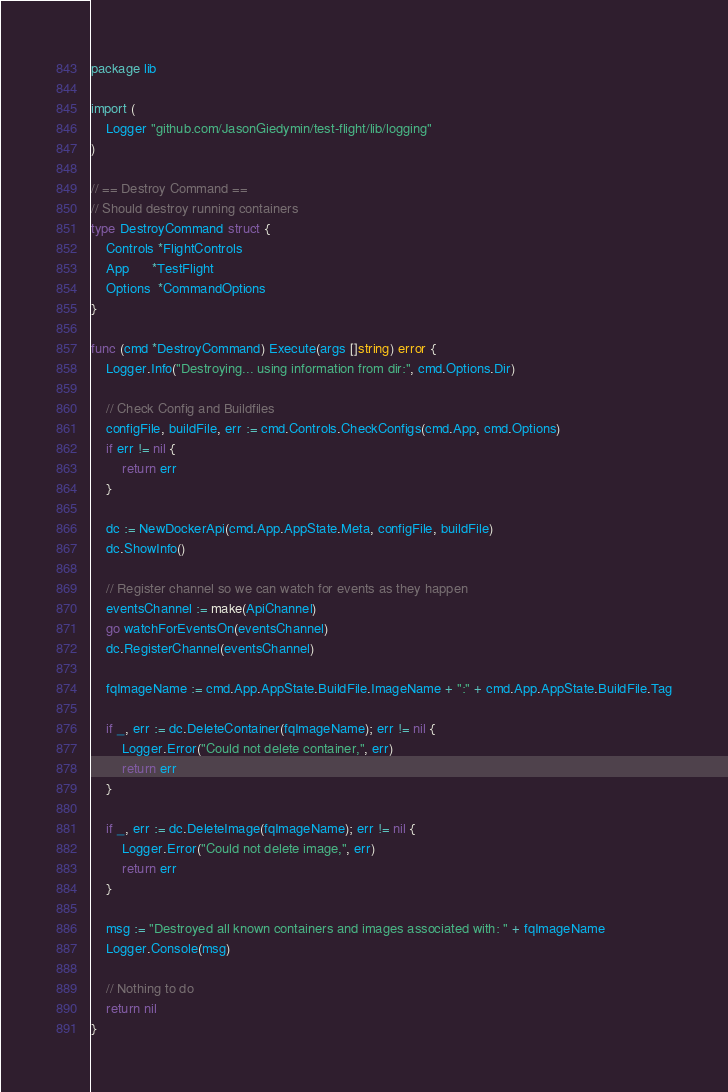<code> <loc_0><loc_0><loc_500><loc_500><_Go_>package lib

import (
    Logger "github.com/JasonGiedymin/test-flight/lib/logging"
)

// == Destroy Command ==
// Should destroy running containers
type DestroyCommand struct {
    Controls *FlightControls
    App      *TestFlight
    Options  *CommandOptions
}

func (cmd *DestroyCommand) Execute(args []string) error {
    Logger.Info("Destroying... using information from dir:", cmd.Options.Dir)

    // Check Config and Buildfiles
    configFile, buildFile, err := cmd.Controls.CheckConfigs(cmd.App, cmd.Options)
    if err != nil {
        return err
    }

    dc := NewDockerApi(cmd.App.AppState.Meta, configFile, buildFile)
    dc.ShowInfo()

    // Register channel so we can watch for events as they happen
    eventsChannel := make(ApiChannel)
    go watchForEventsOn(eventsChannel)
    dc.RegisterChannel(eventsChannel)

    fqImageName := cmd.App.AppState.BuildFile.ImageName + ":" + cmd.App.AppState.BuildFile.Tag

    if _, err := dc.DeleteContainer(fqImageName); err != nil {
        Logger.Error("Could not delete container,", err)
        return err
    }

    if _, err := dc.DeleteImage(fqImageName); err != nil {
        Logger.Error("Could not delete image,", err)
        return err
    }

    msg := "Destroyed all known containers and images associated with: " + fqImageName
    Logger.Console(msg)

    // Nothing to do
    return nil
}
</code> 